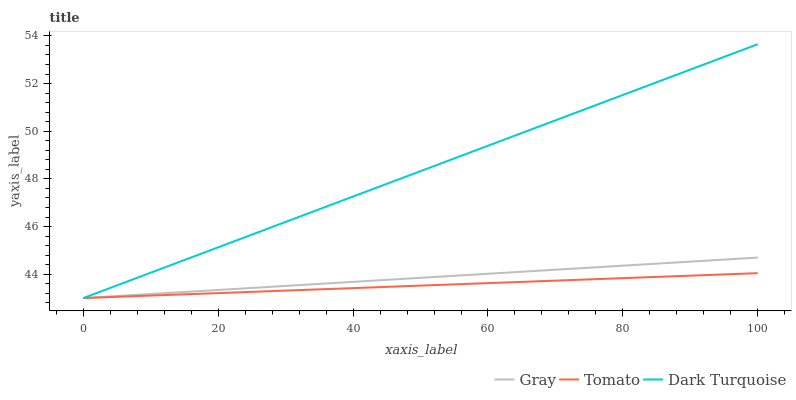Does Tomato have the minimum area under the curve?
Answer yes or no. Yes. Does Dark Turquoise have the maximum area under the curve?
Answer yes or no. Yes. Does Gray have the minimum area under the curve?
Answer yes or no. No. Does Gray have the maximum area under the curve?
Answer yes or no. No. Is Gray the smoothest?
Answer yes or no. Yes. Is Dark Turquoise the roughest?
Answer yes or no. Yes. Is Dark Turquoise the smoothest?
Answer yes or no. No. Is Gray the roughest?
Answer yes or no. No. Does Tomato have the lowest value?
Answer yes or no. Yes. Does Dark Turquoise have the highest value?
Answer yes or no. Yes. Does Gray have the highest value?
Answer yes or no. No. Does Gray intersect Dark Turquoise?
Answer yes or no. Yes. Is Gray less than Dark Turquoise?
Answer yes or no. No. Is Gray greater than Dark Turquoise?
Answer yes or no. No. 